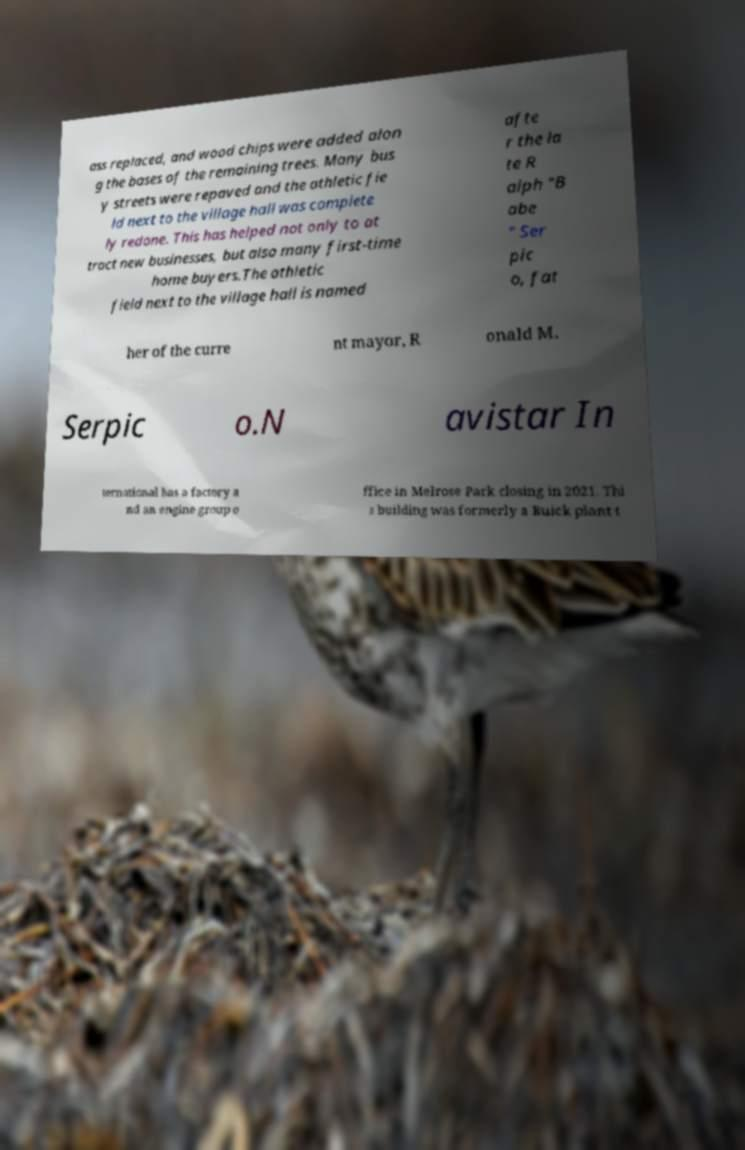Could you assist in decoding the text presented in this image and type it out clearly? ass replaced, and wood chips were added alon g the bases of the remaining trees. Many bus y streets were repaved and the athletic fie ld next to the village hall was complete ly redone. This has helped not only to at tract new businesses, but also many first-time home buyers.The athletic field next to the village hall is named afte r the la te R alph "B abe " Ser pic o, fat her of the curre nt mayor, R onald M. Serpic o.N avistar In ternational has a factory a nd an engine group o ffice in Melrose Park closing in 2021. Thi s building was formerly a Buick plant t 